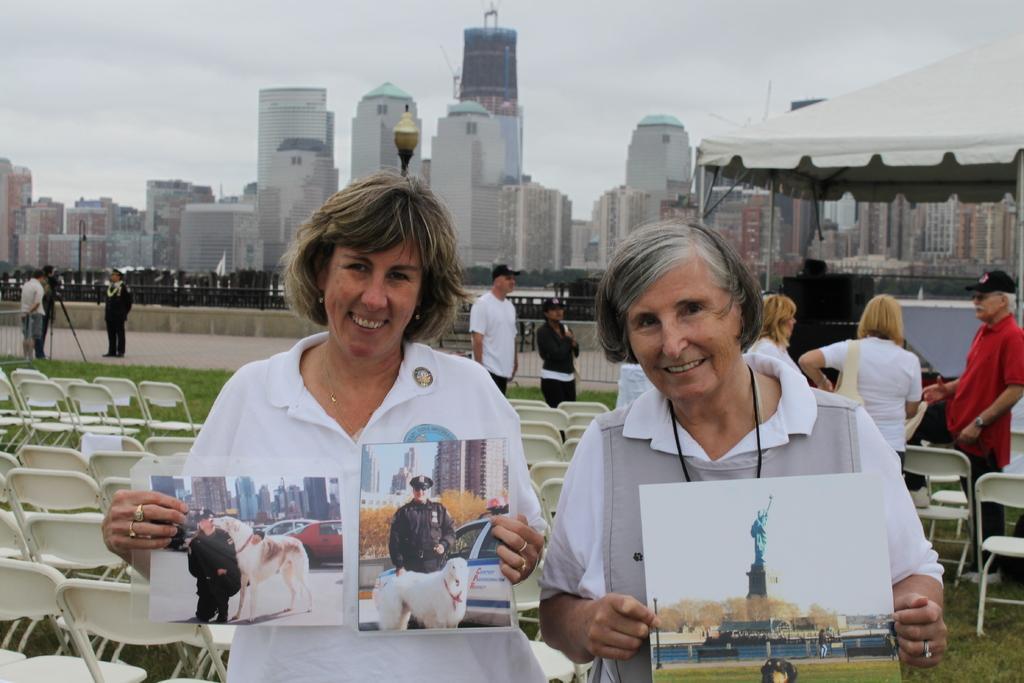Can you describe this image briefly? In this image we can see a few people standing, among them two people are holding photographs, there are some chairs, buildings, fence, pole and a light, in the background we can see the sky. 